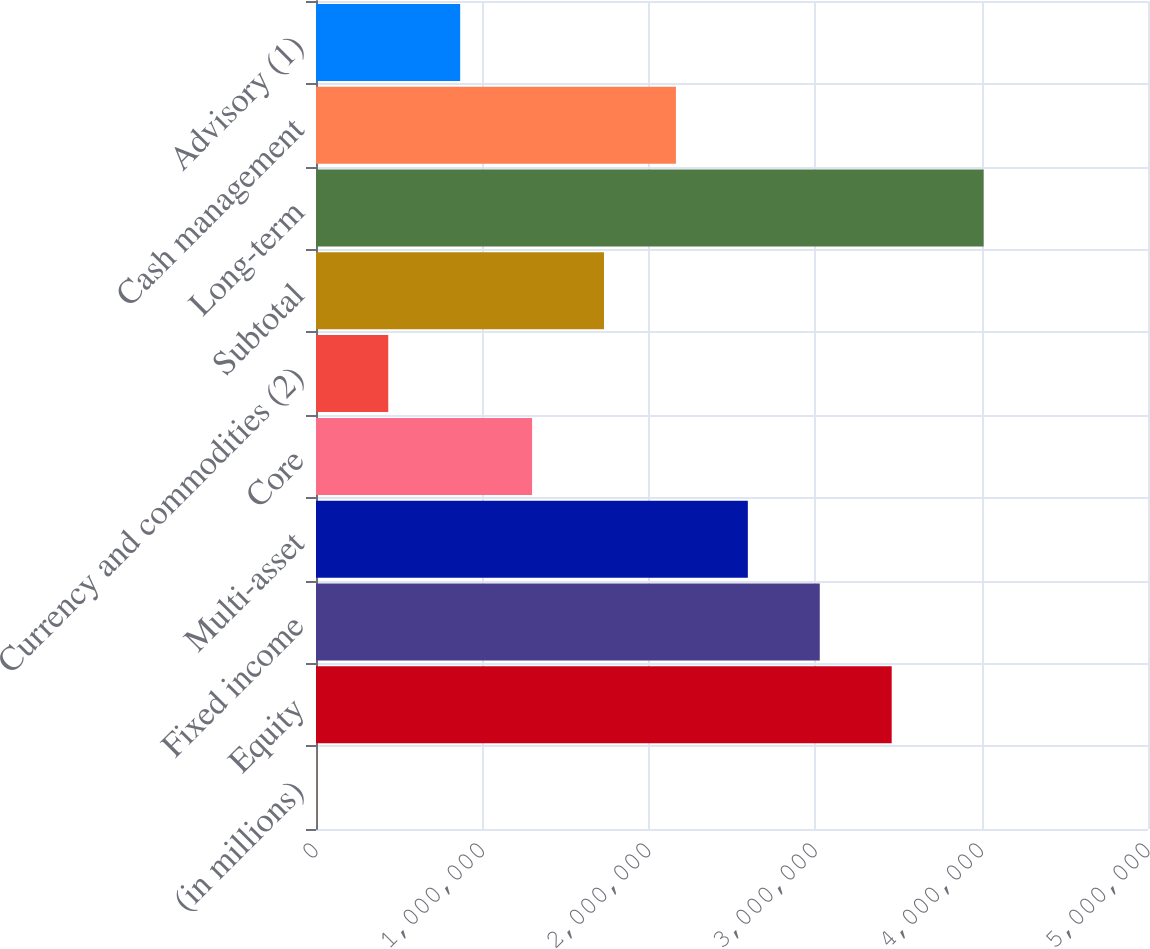Convert chart. <chart><loc_0><loc_0><loc_500><loc_500><bar_chart><fcel>(in millions)<fcel>Equity<fcel>Fixed income<fcel>Multi-asset<fcel>Core<fcel>Currency and commodities (2)<fcel>Subtotal<fcel>Long-term<fcel>Cash management<fcel>Advisory (1)<nl><fcel>2013<fcel>3.45967e+06<fcel>3.02747e+06<fcel>2.59526e+06<fcel>1.29864e+06<fcel>434220<fcel>1.73084e+06<fcel>4.01221e+06<fcel>2.16305e+06<fcel>866428<nl></chart> 